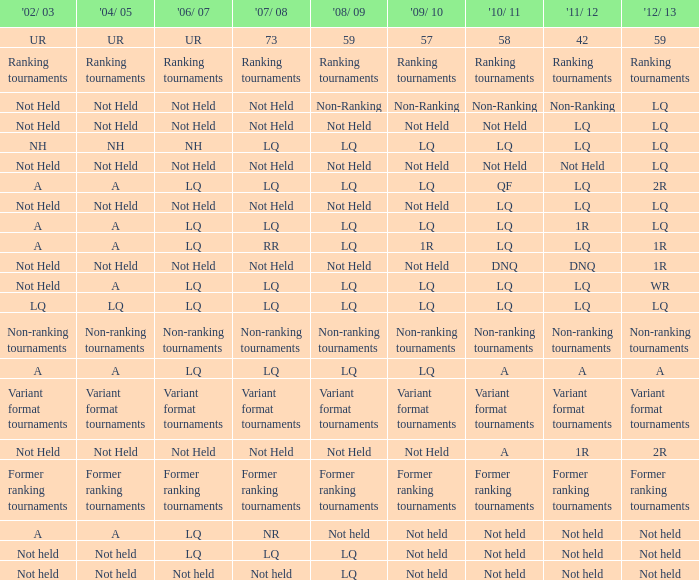Identify the 2010/11 event that was not held in 2004/05 and became non-ranking in 2011/12. Non-Ranking. 